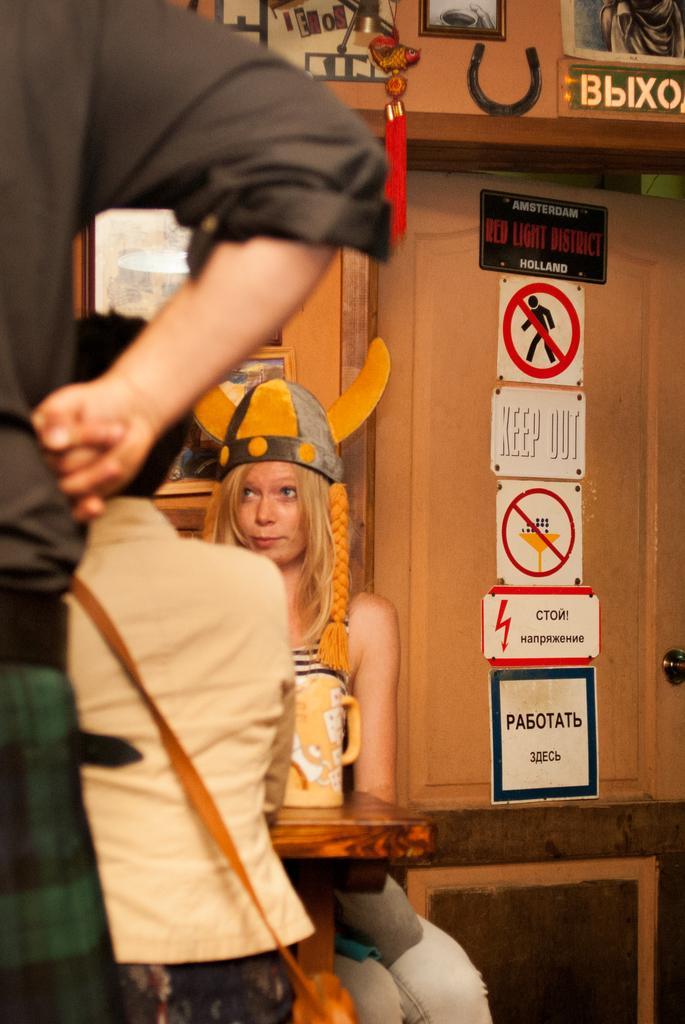In one or two sentences, can you explain what this image depicts? This picture describes about group of people, two are seated and a person is standing, in front of them we can see a jug on the table, in the background we can find few sign boards on the door. 